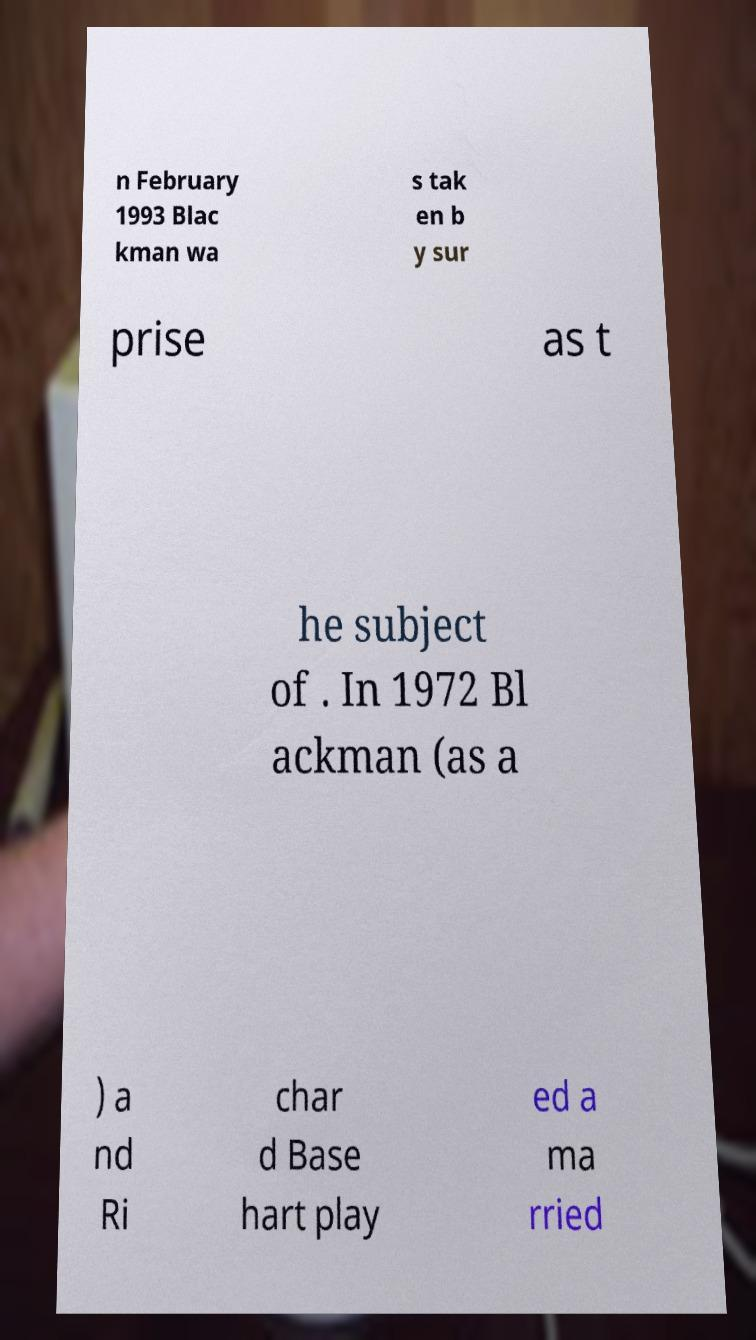For documentation purposes, I need the text within this image transcribed. Could you provide that? n February 1993 Blac kman wa s tak en b y sur prise as t he subject of . In 1972 Bl ackman (as a ) a nd Ri char d Base hart play ed a ma rried 